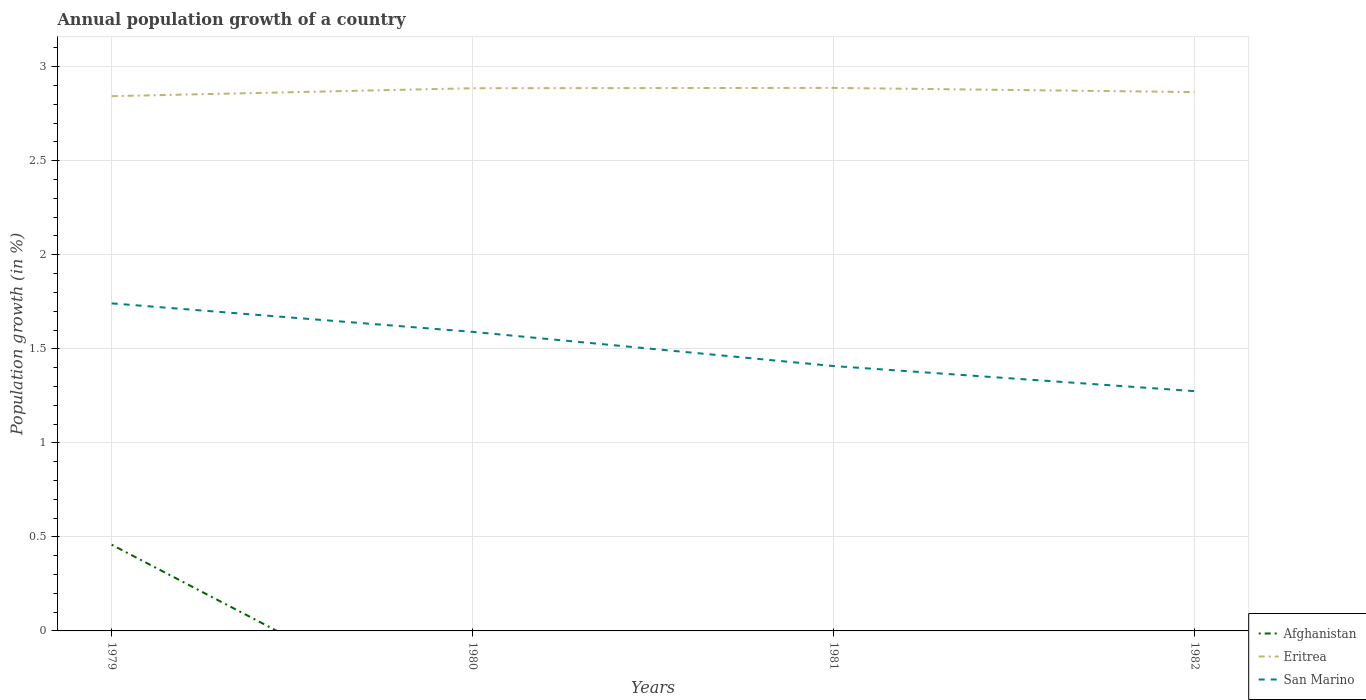How many different coloured lines are there?
Your response must be concise. 3. Does the line corresponding to San Marino intersect with the line corresponding to Afghanistan?
Provide a succinct answer. No. Across all years, what is the maximum annual population growth in San Marino?
Keep it short and to the point. 1.27. What is the total annual population growth in Eritrea in the graph?
Provide a succinct answer. -0.02. What is the difference between the highest and the second highest annual population growth in San Marino?
Give a very brief answer. 0.47. Is the annual population growth in Afghanistan strictly greater than the annual population growth in San Marino over the years?
Your answer should be compact. Yes. Does the graph contain grids?
Provide a succinct answer. Yes. Where does the legend appear in the graph?
Ensure brevity in your answer.  Bottom right. What is the title of the graph?
Provide a short and direct response. Annual population growth of a country. Does "Guinea" appear as one of the legend labels in the graph?
Offer a very short reply. No. What is the label or title of the Y-axis?
Your answer should be very brief. Population growth (in %). What is the Population growth (in %) of Afghanistan in 1979?
Provide a short and direct response. 0.46. What is the Population growth (in %) in Eritrea in 1979?
Provide a short and direct response. 2.84. What is the Population growth (in %) of San Marino in 1979?
Your answer should be very brief. 1.74. What is the Population growth (in %) of Eritrea in 1980?
Provide a succinct answer. 2.89. What is the Population growth (in %) in San Marino in 1980?
Provide a succinct answer. 1.59. What is the Population growth (in %) in Afghanistan in 1981?
Offer a very short reply. 0. What is the Population growth (in %) of Eritrea in 1981?
Give a very brief answer. 2.89. What is the Population growth (in %) in San Marino in 1981?
Your answer should be compact. 1.41. What is the Population growth (in %) of Eritrea in 1982?
Ensure brevity in your answer.  2.87. What is the Population growth (in %) of San Marino in 1982?
Keep it short and to the point. 1.27. Across all years, what is the maximum Population growth (in %) of Afghanistan?
Provide a succinct answer. 0.46. Across all years, what is the maximum Population growth (in %) of Eritrea?
Offer a very short reply. 2.89. Across all years, what is the maximum Population growth (in %) of San Marino?
Your answer should be compact. 1.74. Across all years, what is the minimum Population growth (in %) of Eritrea?
Your response must be concise. 2.84. Across all years, what is the minimum Population growth (in %) of San Marino?
Make the answer very short. 1.27. What is the total Population growth (in %) in Afghanistan in the graph?
Your answer should be very brief. 0.46. What is the total Population growth (in %) in Eritrea in the graph?
Ensure brevity in your answer.  11.48. What is the total Population growth (in %) of San Marino in the graph?
Offer a very short reply. 6.01. What is the difference between the Population growth (in %) of Eritrea in 1979 and that in 1980?
Your answer should be very brief. -0.04. What is the difference between the Population growth (in %) in San Marino in 1979 and that in 1980?
Provide a succinct answer. 0.15. What is the difference between the Population growth (in %) in Eritrea in 1979 and that in 1981?
Offer a very short reply. -0.04. What is the difference between the Population growth (in %) in San Marino in 1979 and that in 1981?
Offer a very short reply. 0.33. What is the difference between the Population growth (in %) in Eritrea in 1979 and that in 1982?
Your response must be concise. -0.02. What is the difference between the Population growth (in %) in San Marino in 1979 and that in 1982?
Offer a terse response. 0.47. What is the difference between the Population growth (in %) of Eritrea in 1980 and that in 1981?
Your response must be concise. -0. What is the difference between the Population growth (in %) in San Marino in 1980 and that in 1981?
Your answer should be very brief. 0.18. What is the difference between the Population growth (in %) in Eritrea in 1980 and that in 1982?
Offer a terse response. 0.02. What is the difference between the Population growth (in %) in San Marino in 1980 and that in 1982?
Ensure brevity in your answer.  0.32. What is the difference between the Population growth (in %) of Eritrea in 1981 and that in 1982?
Your response must be concise. 0.02. What is the difference between the Population growth (in %) of San Marino in 1981 and that in 1982?
Offer a very short reply. 0.13. What is the difference between the Population growth (in %) in Afghanistan in 1979 and the Population growth (in %) in Eritrea in 1980?
Give a very brief answer. -2.43. What is the difference between the Population growth (in %) in Afghanistan in 1979 and the Population growth (in %) in San Marino in 1980?
Ensure brevity in your answer.  -1.13. What is the difference between the Population growth (in %) in Eritrea in 1979 and the Population growth (in %) in San Marino in 1980?
Make the answer very short. 1.25. What is the difference between the Population growth (in %) in Afghanistan in 1979 and the Population growth (in %) in Eritrea in 1981?
Your answer should be compact. -2.43. What is the difference between the Population growth (in %) of Afghanistan in 1979 and the Population growth (in %) of San Marino in 1981?
Your response must be concise. -0.95. What is the difference between the Population growth (in %) of Eritrea in 1979 and the Population growth (in %) of San Marino in 1981?
Make the answer very short. 1.43. What is the difference between the Population growth (in %) of Afghanistan in 1979 and the Population growth (in %) of Eritrea in 1982?
Your answer should be compact. -2.41. What is the difference between the Population growth (in %) in Afghanistan in 1979 and the Population growth (in %) in San Marino in 1982?
Keep it short and to the point. -0.82. What is the difference between the Population growth (in %) in Eritrea in 1979 and the Population growth (in %) in San Marino in 1982?
Make the answer very short. 1.57. What is the difference between the Population growth (in %) in Eritrea in 1980 and the Population growth (in %) in San Marino in 1981?
Give a very brief answer. 1.48. What is the difference between the Population growth (in %) of Eritrea in 1980 and the Population growth (in %) of San Marino in 1982?
Your answer should be compact. 1.61. What is the difference between the Population growth (in %) of Eritrea in 1981 and the Population growth (in %) of San Marino in 1982?
Ensure brevity in your answer.  1.61. What is the average Population growth (in %) in Afghanistan per year?
Give a very brief answer. 0.11. What is the average Population growth (in %) of Eritrea per year?
Make the answer very short. 2.87. What is the average Population growth (in %) of San Marino per year?
Offer a terse response. 1.5. In the year 1979, what is the difference between the Population growth (in %) of Afghanistan and Population growth (in %) of Eritrea?
Provide a succinct answer. -2.38. In the year 1979, what is the difference between the Population growth (in %) in Afghanistan and Population growth (in %) in San Marino?
Offer a terse response. -1.28. In the year 1979, what is the difference between the Population growth (in %) in Eritrea and Population growth (in %) in San Marino?
Your answer should be very brief. 1.1. In the year 1980, what is the difference between the Population growth (in %) of Eritrea and Population growth (in %) of San Marino?
Your response must be concise. 1.3. In the year 1981, what is the difference between the Population growth (in %) in Eritrea and Population growth (in %) in San Marino?
Your answer should be very brief. 1.48. In the year 1982, what is the difference between the Population growth (in %) of Eritrea and Population growth (in %) of San Marino?
Provide a short and direct response. 1.59. What is the ratio of the Population growth (in %) in Eritrea in 1979 to that in 1980?
Provide a short and direct response. 0.99. What is the ratio of the Population growth (in %) in San Marino in 1979 to that in 1980?
Offer a very short reply. 1.1. What is the ratio of the Population growth (in %) in San Marino in 1979 to that in 1981?
Give a very brief answer. 1.24. What is the ratio of the Population growth (in %) in Eritrea in 1979 to that in 1982?
Offer a terse response. 0.99. What is the ratio of the Population growth (in %) of San Marino in 1979 to that in 1982?
Your response must be concise. 1.37. What is the ratio of the Population growth (in %) of Eritrea in 1980 to that in 1981?
Give a very brief answer. 1. What is the ratio of the Population growth (in %) of San Marino in 1980 to that in 1981?
Offer a very short reply. 1.13. What is the ratio of the Population growth (in %) of Eritrea in 1980 to that in 1982?
Your answer should be compact. 1.01. What is the ratio of the Population growth (in %) of San Marino in 1980 to that in 1982?
Provide a short and direct response. 1.25. What is the ratio of the Population growth (in %) of Eritrea in 1981 to that in 1982?
Your response must be concise. 1.01. What is the ratio of the Population growth (in %) in San Marino in 1981 to that in 1982?
Give a very brief answer. 1.1. What is the difference between the highest and the second highest Population growth (in %) of Eritrea?
Provide a succinct answer. 0. What is the difference between the highest and the second highest Population growth (in %) in San Marino?
Your answer should be compact. 0.15. What is the difference between the highest and the lowest Population growth (in %) of Afghanistan?
Provide a succinct answer. 0.46. What is the difference between the highest and the lowest Population growth (in %) of Eritrea?
Your answer should be compact. 0.04. What is the difference between the highest and the lowest Population growth (in %) of San Marino?
Provide a short and direct response. 0.47. 